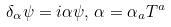Convert formula to latex. <formula><loc_0><loc_0><loc_500><loc_500>\delta _ { \alpha } \psi = i \alpha \psi , \, \alpha = \alpha _ { a } T ^ { a }</formula> 